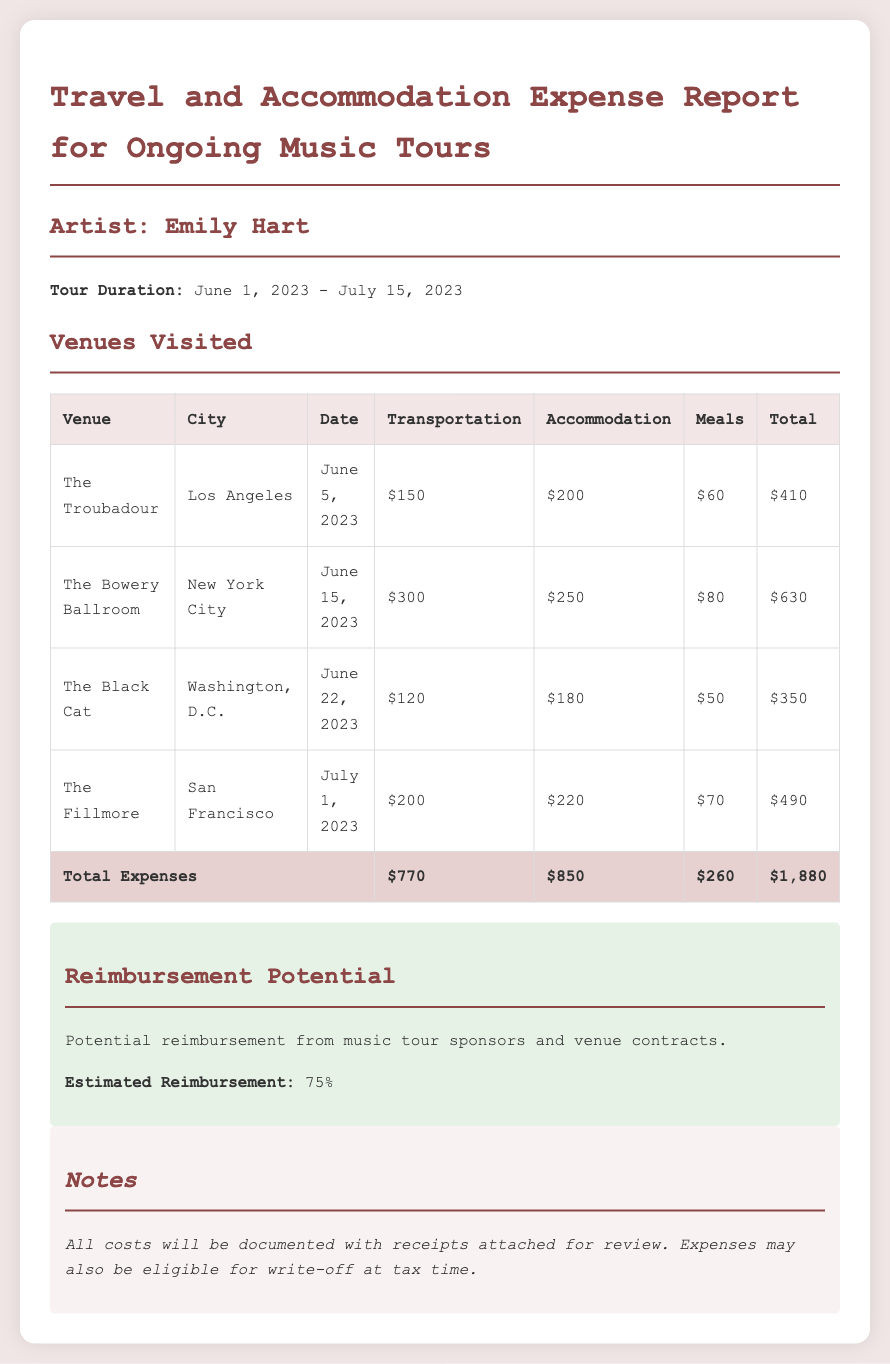What is the total amount spent on transportation? The total amount spent on transportation is the sum of transportation costs for all venues, calculated as $150 + $300 + $120 + $200 = $770.
Answer: $770 What is the highest accommodation cost incurred? The highest accommodation cost is found by comparing the accommodation expenses, which are $200, $250, $180, and $220. The highest is $250.
Answer: $250 Which city had the venue with the lowest total expenses? The venue with the lowest total expenses can be determined from the total expenses column, where The Black Cat in Washington, D.C. costs $350, which is the lowest.
Answer: Washington, D.C What percentage of the total expenses is eligible for reimbursement? The estimated reimbursement is based on a percentage stated in the report, which indicates that 75% of total expenses are reimbursable.
Answer: 75% When was the performance at The Fillmore? The performance date is indicated next to the venue name, which shows that it occurred on July 1, 2023.
Answer: July 1, 2023 What is the total cost incurred for meals? The total meal costs can be calculated by adding the meal expenses, which are $60, $80, $50, and $70, resulting in $260.
Answer: $260 What is the total reimbursement potential? The reimbursement potential is based on the overall total expenses and the estimated percentage of reimbursement. Total expenses are $1,880, and 75% of that is $1,410.
Answer: $1,410 What is the venue's name in Los Angeles? The name of the venue in Los Angeles is specifically mentioned in the document as The Troubadour.
Answer: The Troubadour 